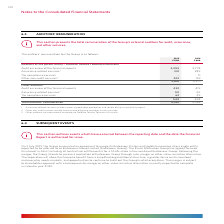According to Woolworths Limited's financial document, What is the unit used in the table? According to the financial document, $’000. The relevant text states: "2019 2018 $’000 $’000..." Also, What is the total auditors' remuneration in 2019? According to the financial document, 4,162 (in thousands). The relevant text states: "rvices 62 29 544 498 Total auditors’ remuneration 4,162 3,769..." Also, What is the meaning of assurance related service in the context of the table? Assurance related services include various agreed upon procedures and review of the sustainability report.. The document states: "1 Assurance related services include various agreed upon procedures and review of the sustainability report. 2 Other non-audit services include financ..." Also, can you calculate: What is the difference in the total auditors' remuneration between 2018 and 2019? Based on the calculation: 4,162 - 3,769 , the result is 393 (in thousands). This is based on the information: "rvices 62 29 544 498 Total auditors’ remuneration 4,162 3,769 62 29 544 498 Total auditors’ remuneration 4,162 3,769..." The key data points involved are: 3,769, 4,162. Also, can you calculate: In 2019, what is the percentage constitution of Deloitte Touche Tohmatsu Australia's remuneration in the total auditors' remuneration? Based on the calculation: 3,618/4,162 , the result is 86.93 (percentage). This is based on the information: "rvices 62 29 544 498 Total auditors’ remuneration 4,162 3,769 services – 11 Other non-audit services 2 222 193 3,618 3,271 Other auditors 3..." The key data points involved are: 3,618, 4,162. Also, can you calculate: For the other auditors, what is the percentage change of tax compliance service from 2018 to 2019? To answer this question, I need to perform calculations using the financial data. The calculation is: (62-29)/29 , which equals 113.79 (percentage). This is based on the information: "related services 1 50 50 Tax compliance services 62 29 544 498 Total auditors’ remuneration 4,162 3,769 lated services 1 50 50 Tax compliance services 62 29 544 498 Total auditors’ remuneration 4,162 ..." The key data points involved are: 29, 62. 